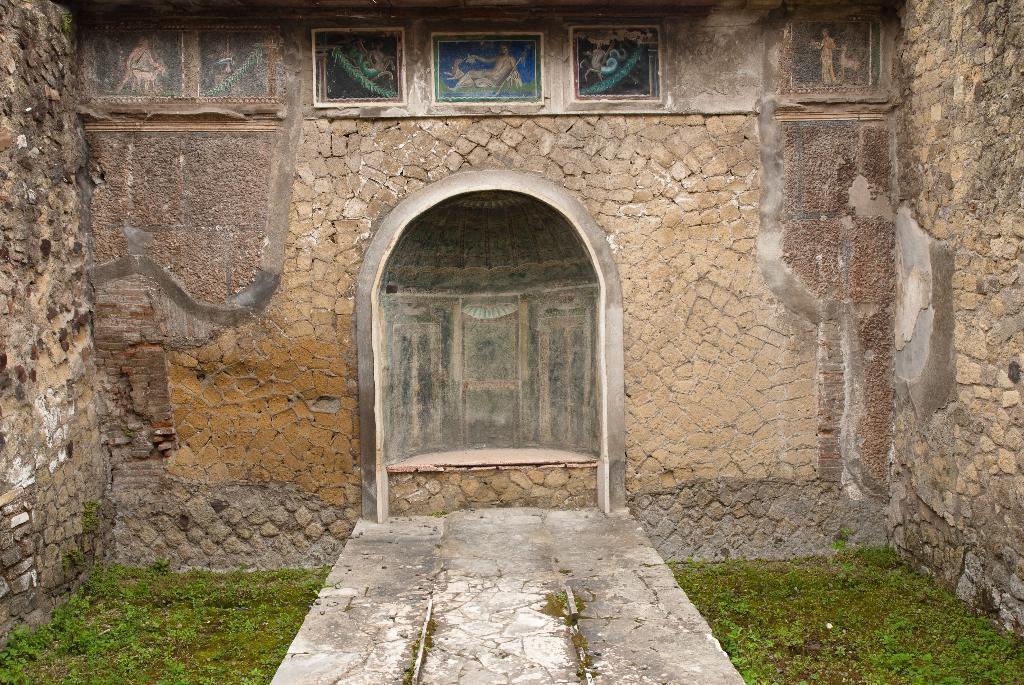Please provide a concise description of this image. In the picture we can see a historical construction of walls and some part of it are damaged and to the wall we can see some paintings and near the wall we can see a path and on the either sides we can see a grass surface. 